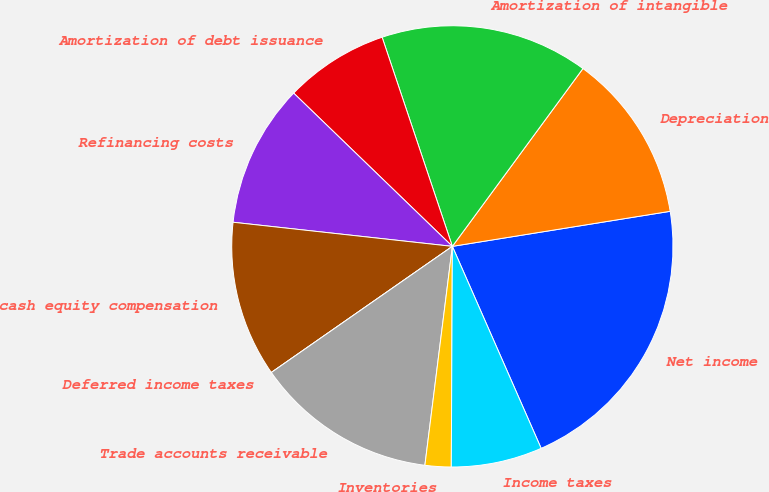Convert chart. <chart><loc_0><loc_0><loc_500><loc_500><pie_chart><fcel>Net income<fcel>Depreciation<fcel>Amortization of intangible<fcel>Amortization of debt issuance<fcel>Refinancing costs<fcel>Non-cash equity compensation<fcel>Deferred income taxes<fcel>Trade accounts receivable<fcel>Inventories<fcel>Income taxes<nl><fcel>20.95%<fcel>12.38%<fcel>15.24%<fcel>7.62%<fcel>10.48%<fcel>11.43%<fcel>0.0%<fcel>13.33%<fcel>1.91%<fcel>6.67%<nl></chart> 